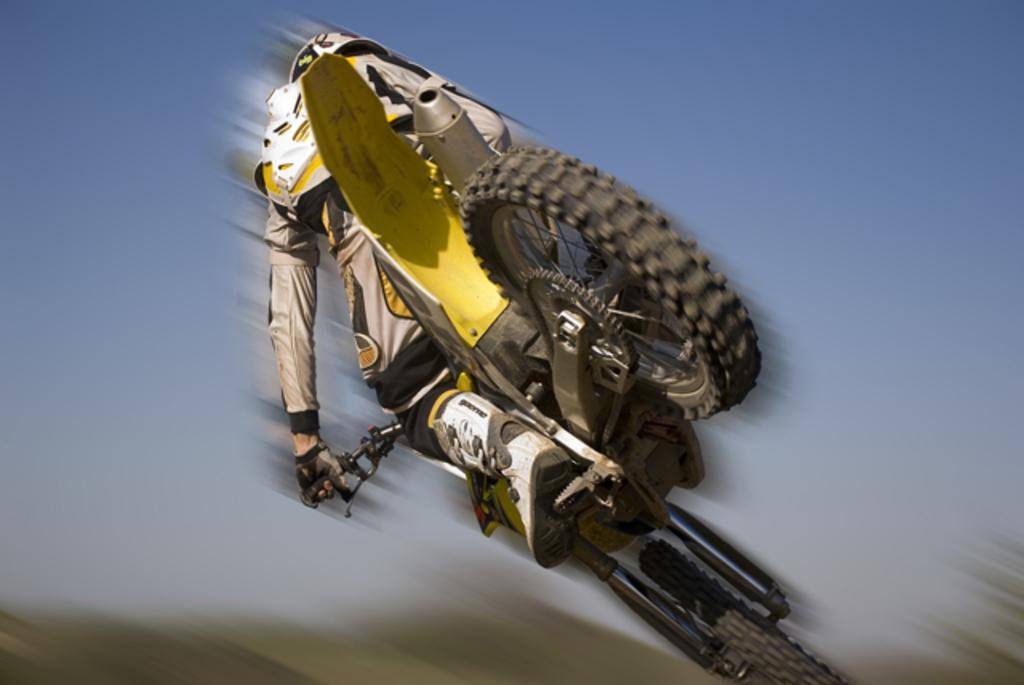What is the main subject of the image? There is a person in the image. What is the person doing in the image? The person is riding a bike. Can you describe the background of the image? The background of the image is blurred. How many apples can be seen on the person's flight in the image? There is no flight or apples present in the image; it features a person riding a bike with a blurred background. 